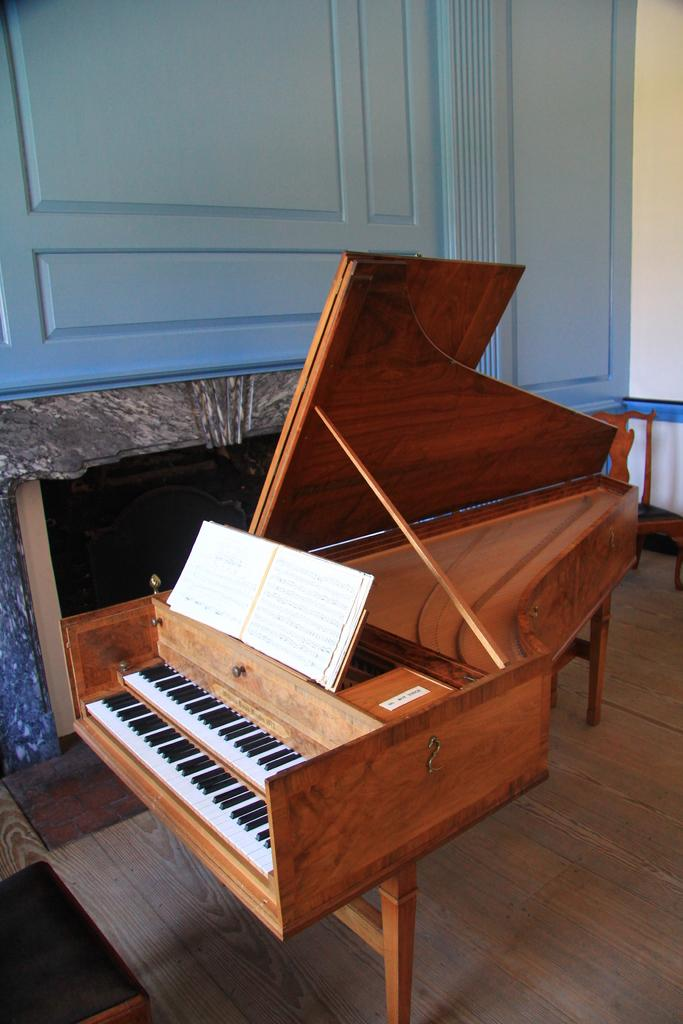What musical instrument is present in the image? There is a piano on the floor in the image. What non-musical item can be seen in the image? There is a book in the image. What type of structure is visible in the image? There is a wall in the image. Can you see any bees buzzing around the piano in the image? There are no bees present in the image. Is the piano located in a cellar in the image? The image does not provide information about the location of the piano, such as whether it is in a cellar or not. 